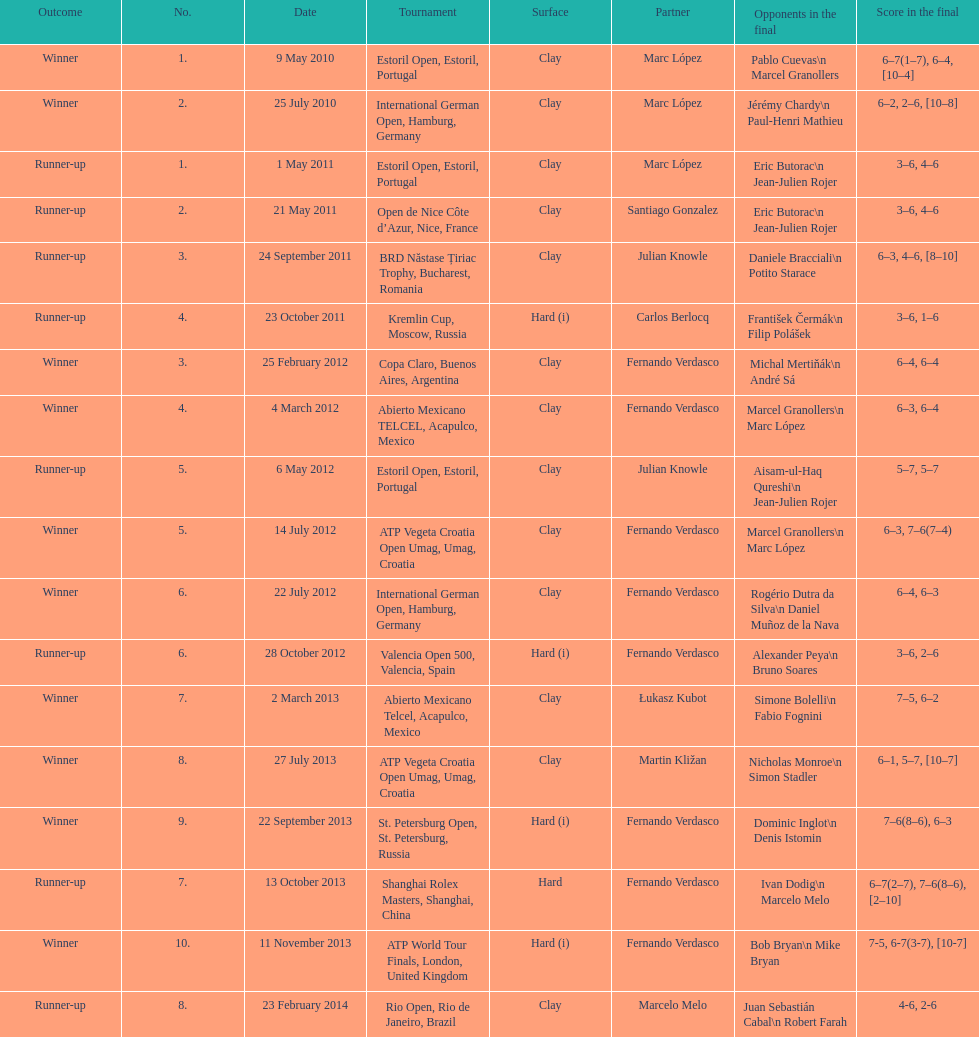What is the quantity of victorious results? 10. 